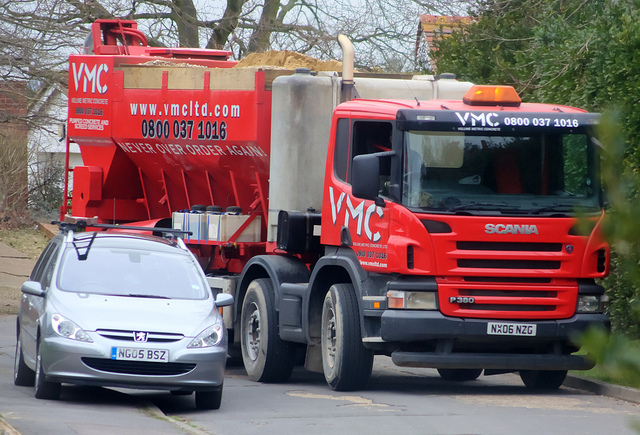Please transcribe the text information in this image. VMC VMC NG05 BSZ VMC SCANIA NX05 NZG WWW.Vmcltd.com 0800 037 1016 NEVER OVER ORDER AGAIN 1016 037 0800 300 